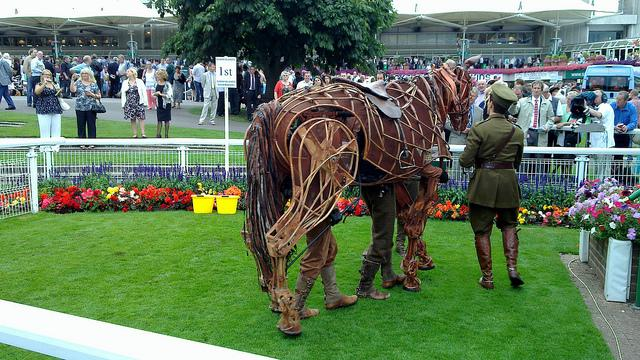What is inside of the horse sculpture? people 